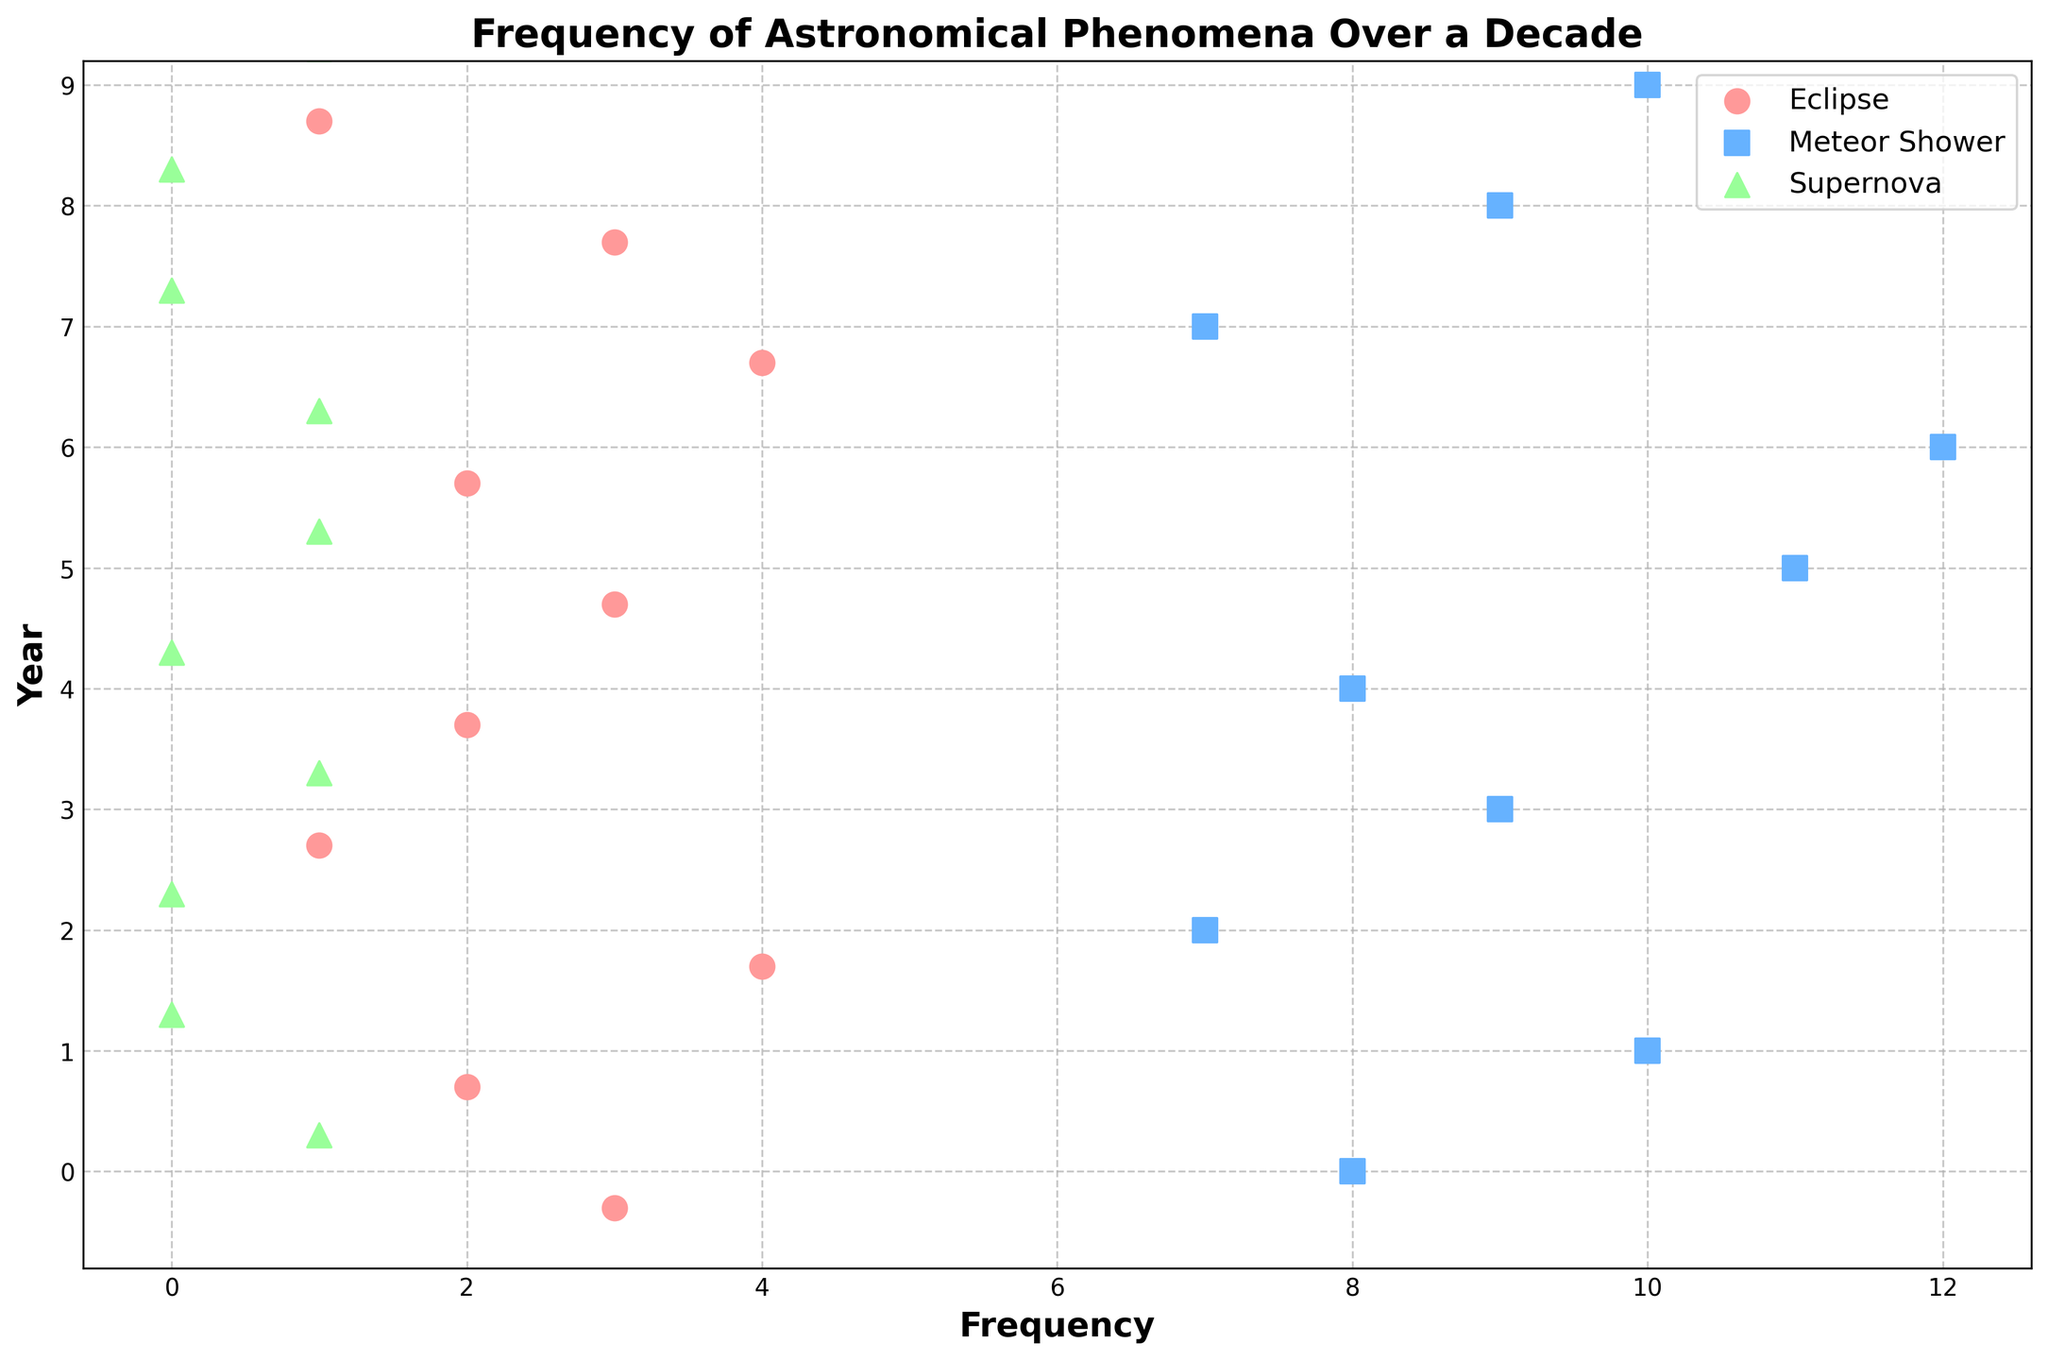What's the title of the plot? Look at the large text at the top of the plot. It describes the main subject of the figure.
Answer: Frequency of Astronomical Phenomena Over a Decade How many total years are shown in the plot? Count the number of unique years listed on the y-axis.
Answer: 10 years Which astronomical phenomenon has the highest frequency in any single year? Identify the data point with the highest x-value (frequency) and note its associated phenomenon. The meteor shower has the dot with the highest frequency. Specifically, Year 7 has 12 meteor showers.
Answer: Meteor Shower In which year were eclipses observed the most frequently? Find the year where the dot for eclipses is further to the right on the x-axis, indicating a higher frequency.
Answer: Year 3 and Year 8 (both have 4 eclipses) What is the average number of supernovas observed across all the years? Add up the number of supernovas observed in each year and divide by the total number of years (1+0+0+1+0+1+1+0+0+1) / 10 = 5/10
Answer: 0.5 per year In which year(s) did meteor showers occur more than 10 times? Look for years where the dot for meteor showers is positioned greater than 10 on the x-axis.
Answer: Year 6 and Year 7 Compare the frequency of eclipses and supernovas in Year 10. Which phenomenon was observed more frequently? Look at the position of the dots corresponding to eclipses and supernovas for Year 10; compare their x-values. Eclipses are at 1 whereas supernovas are at 1 as well but since the question asks which is observed "more frequently", neither is more frequent as they are equal.
Answer: Equal What's the median frequency of meteor showers across all years? To find the median frequency, list the frequencies for meteor showers (8, 10, 7, 9, 8, 11, 12, 7, 9, 10) in ascending order (7, 7, 8, 8, 9, 9, 10, 10, 11, 12) and locate the middle value. With 10 records, the median is the average of the 5th and 6th values, which are both 9.
Answer: 9 Which year had the highest combined (total) frequency for all three phenomena? Sum the frequencies of eclipses, meteor showers, and supernovas for each year and identify the year with the highest total. Year 6 and Year 7 both have the highest combined frequency (3+11+1=15 for Year 6 and 2+12+1=15 for Year 7).
Answer: Year 6 and Year 7 